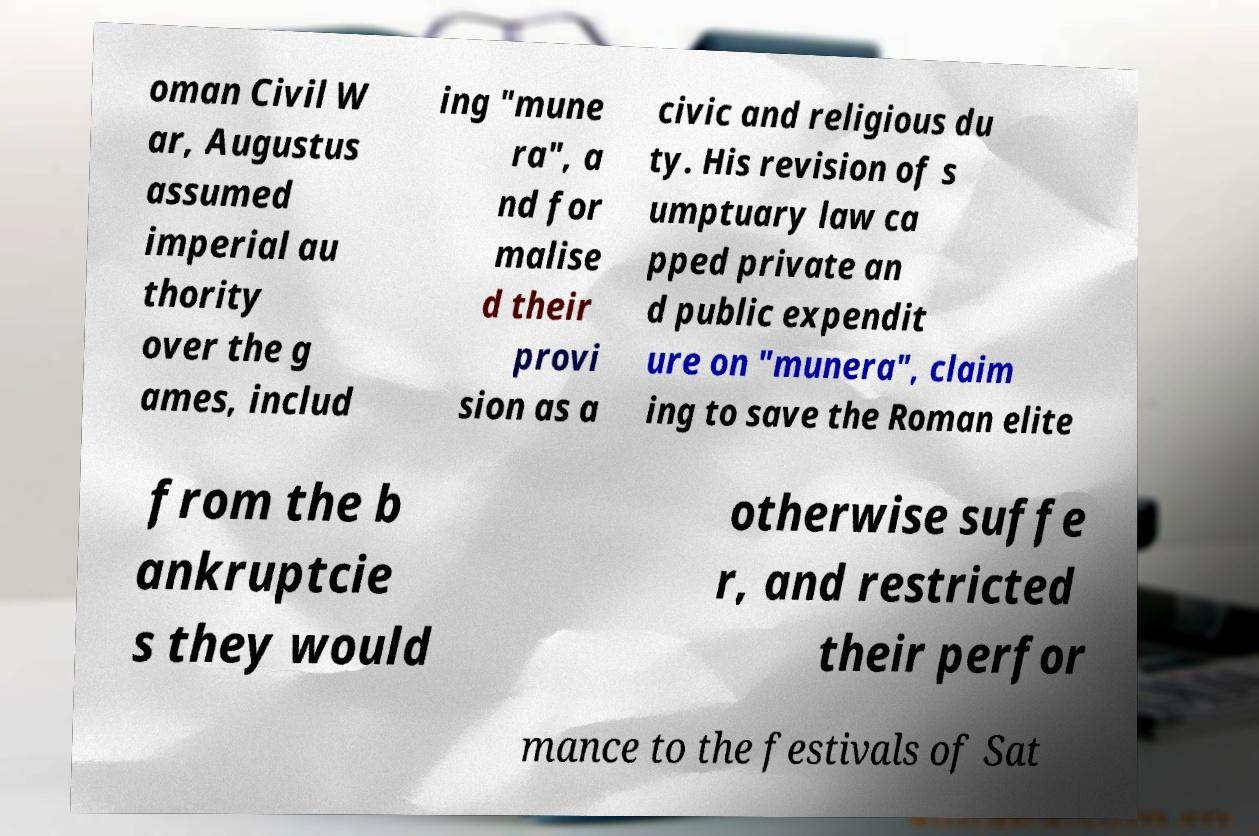Can you read and provide the text displayed in the image?This photo seems to have some interesting text. Can you extract and type it out for me? oman Civil W ar, Augustus assumed imperial au thority over the g ames, includ ing "mune ra", a nd for malise d their provi sion as a civic and religious du ty. His revision of s umptuary law ca pped private an d public expendit ure on "munera", claim ing to save the Roman elite from the b ankruptcie s they would otherwise suffe r, and restricted their perfor mance to the festivals of Sat 